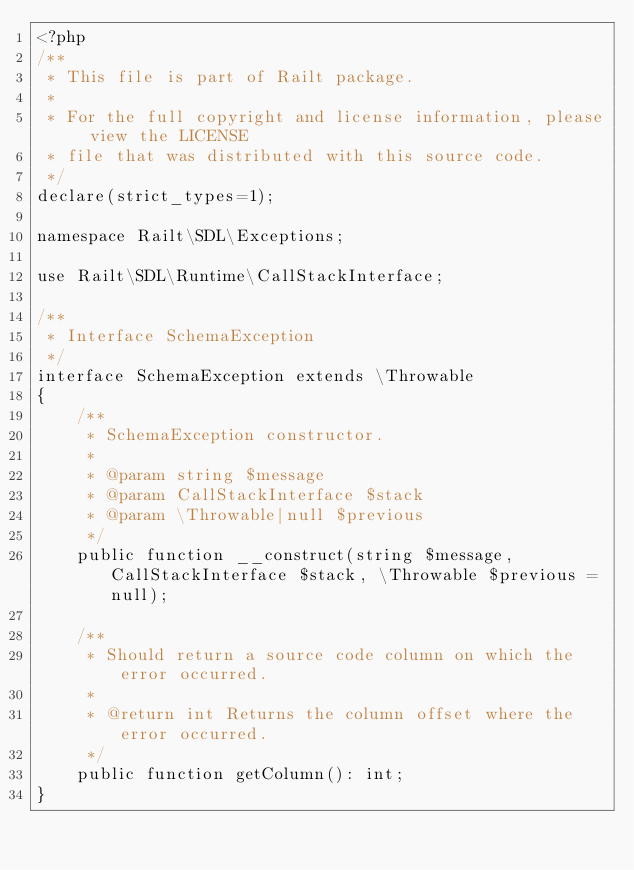<code> <loc_0><loc_0><loc_500><loc_500><_PHP_><?php
/**
 * This file is part of Railt package.
 *
 * For the full copyright and license information, please view the LICENSE
 * file that was distributed with this source code.
 */
declare(strict_types=1);

namespace Railt\SDL\Exceptions;

use Railt\SDL\Runtime\CallStackInterface;

/**
 * Interface SchemaException
 */
interface SchemaException extends \Throwable
{
    /**
     * SchemaException constructor.
     *
     * @param string $message
     * @param CallStackInterface $stack
     * @param \Throwable|null $previous
     */
    public function __construct(string $message, CallStackInterface $stack, \Throwable $previous = null);

    /**
     * Should return a source code column on which the error occurred.
     *
     * @return int Returns the column offset where the error occurred.
     */
    public function getColumn(): int;
}
</code> 